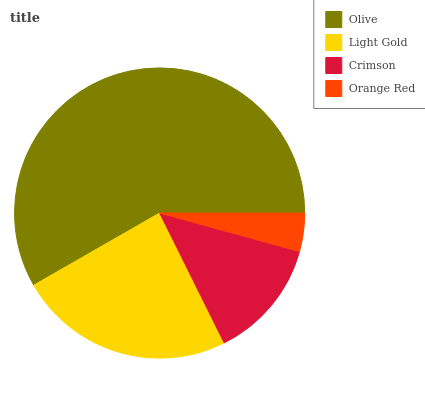Is Orange Red the minimum?
Answer yes or no. Yes. Is Olive the maximum?
Answer yes or no. Yes. Is Light Gold the minimum?
Answer yes or no. No. Is Light Gold the maximum?
Answer yes or no. No. Is Olive greater than Light Gold?
Answer yes or no. Yes. Is Light Gold less than Olive?
Answer yes or no. Yes. Is Light Gold greater than Olive?
Answer yes or no. No. Is Olive less than Light Gold?
Answer yes or no. No. Is Light Gold the high median?
Answer yes or no. Yes. Is Crimson the low median?
Answer yes or no. Yes. Is Orange Red the high median?
Answer yes or no. No. Is Light Gold the low median?
Answer yes or no. No. 